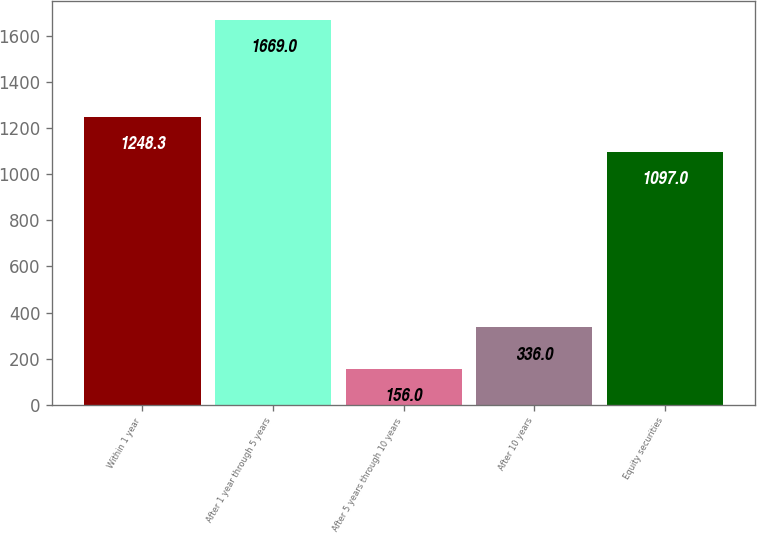Convert chart to OTSL. <chart><loc_0><loc_0><loc_500><loc_500><bar_chart><fcel>Within 1 year<fcel>After 1 year through 5 years<fcel>After 5 years through 10 years<fcel>After 10 years<fcel>Equity securities<nl><fcel>1248.3<fcel>1669<fcel>156<fcel>336<fcel>1097<nl></chart> 